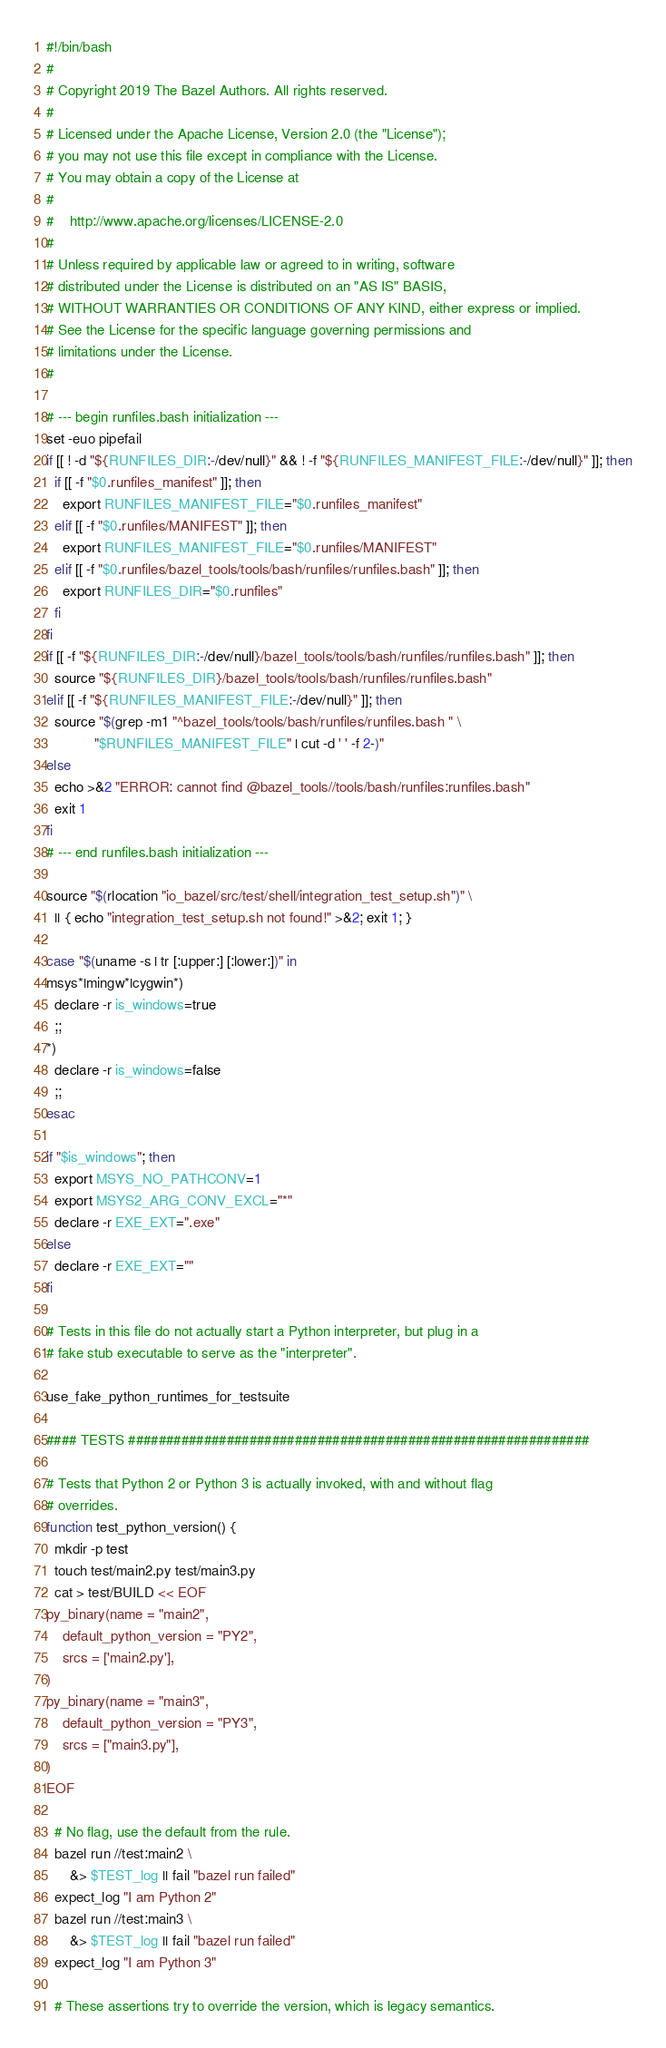<code> <loc_0><loc_0><loc_500><loc_500><_Bash_>#!/bin/bash
#
# Copyright 2019 The Bazel Authors. All rights reserved.
#
# Licensed under the Apache License, Version 2.0 (the "License");
# you may not use this file except in compliance with the License.
# You may obtain a copy of the License at
#
#    http://www.apache.org/licenses/LICENSE-2.0
#
# Unless required by applicable law or agreed to in writing, software
# distributed under the License is distributed on an "AS IS" BASIS,
# WITHOUT WARRANTIES OR CONDITIONS OF ANY KIND, either express or implied.
# See the License for the specific language governing permissions and
# limitations under the License.
#

# --- begin runfiles.bash initialization ---
set -euo pipefail
if [[ ! -d "${RUNFILES_DIR:-/dev/null}" && ! -f "${RUNFILES_MANIFEST_FILE:-/dev/null}" ]]; then
  if [[ -f "$0.runfiles_manifest" ]]; then
    export RUNFILES_MANIFEST_FILE="$0.runfiles_manifest"
  elif [[ -f "$0.runfiles/MANIFEST" ]]; then
    export RUNFILES_MANIFEST_FILE="$0.runfiles/MANIFEST"
  elif [[ -f "$0.runfiles/bazel_tools/tools/bash/runfiles/runfiles.bash" ]]; then
    export RUNFILES_DIR="$0.runfiles"
  fi
fi
if [[ -f "${RUNFILES_DIR:-/dev/null}/bazel_tools/tools/bash/runfiles/runfiles.bash" ]]; then
  source "${RUNFILES_DIR}/bazel_tools/tools/bash/runfiles/runfiles.bash"
elif [[ -f "${RUNFILES_MANIFEST_FILE:-/dev/null}" ]]; then
  source "$(grep -m1 "^bazel_tools/tools/bash/runfiles/runfiles.bash " \
            "$RUNFILES_MANIFEST_FILE" | cut -d ' ' -f 2-)"
else
  echo >&2 "ERROR: cannot find @bazel_tools//tools/bash/runfiles:runfiles.bash"
  exit 1
fi
# --- end runfiles.bash initialization ---

source "$(rlocation "io_bazel/src/test/shell/integration_test_setup.sh")" \
  || { echo "integration_test_setup.sh not found!" >&2; exit 1; }

case "$(uname -s | tr [:upper:] [:lower:])" in
msys*|mingw*|cygwin*)
  declare -r is_windows=true
  ;;
*)
  declare -r is_windows=false
  ;;
esac

if "$is_windows"; then
  export MSYS_NO_PATHCONV=1
  export MSYS2_ARG_CONV_EXCL="*"
  declare -r EXE_EXT=".exe"
else
  declare -r EXE_EXT=""
fi

# Tests in this file do not actually start a Python interpreter, but plug in a
# fake stub executable to serve as the "interpreter".

use_fake_python_runtimes_for_testsuite

#### TESTS #############################################################

# Tests that Python 2 or Python 3 is actually invoked, with and without flag
# overrides.
function test_python_version() {
  mkdir -p test
  touch test/main2.py test/main3.py
  cat > test/BUILD << EOF
py_binary(name = "main2",
    default_python_version = "PY2",
    srcs = ['main2.py'],
)
py_binary(name = "main3",
    default_python_version = "PY3",
    srcs = ["main3.py"],
)
EOF

  # No flag, use the default from the rule.
  bazel run //test:main2 \
      &> $TEST_log || fail "bazel run failed"
  expect_log "I am Python 2"
  bazel run //test:main3 \
      &> $TEST_log || fail "bazel run failed"
  expect_log "I am Python 3"

  # These assertions try to override the version, which is legacy semantics.</code> 